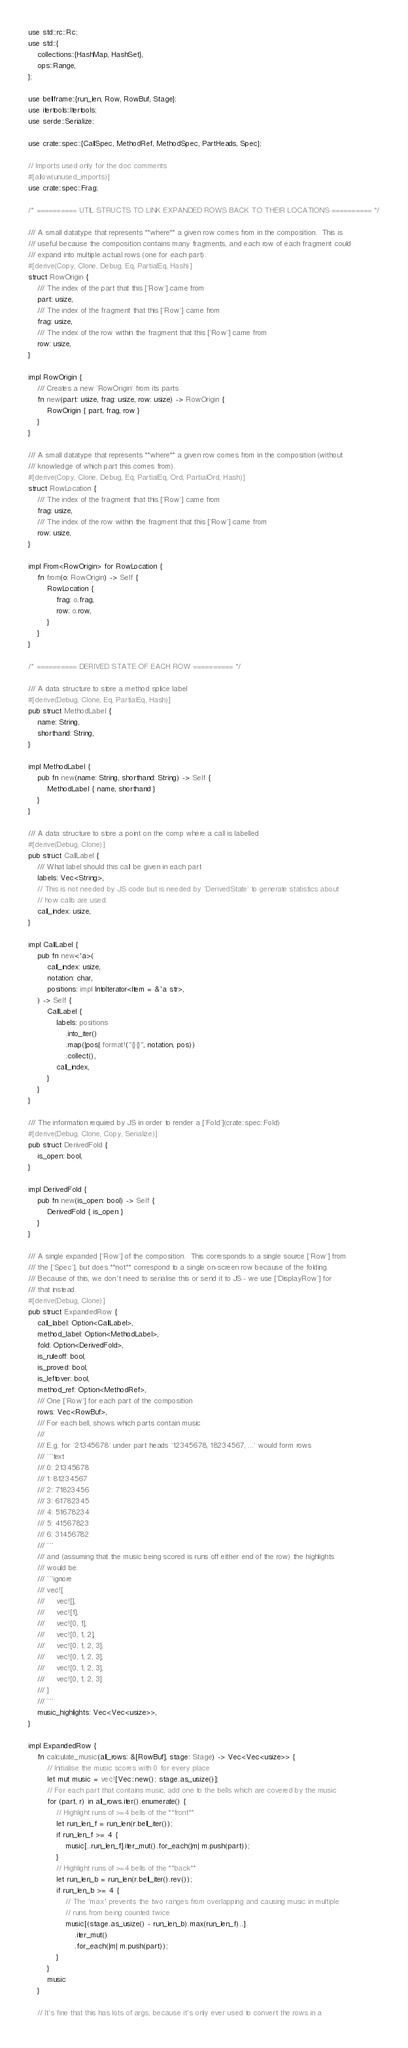<code> <loc_0><loc_0><loc_500><loc_500><_Rust_>use std::rc::Rc;
use std::{
    collections::{HashMap, HashSet},
    ops::Range,
};

use bellframe::{run_len, Row, RowBuf, Stage};
use itertools::Itertools;
use serde::Serialize;

use crate::spec::{CallSpec, MethodRef, MethodSpec, PartHeads, Spec};

// Imports used only for the doc comments
#[allow(unused_imports)]
use crate::spec::Frag;

/* ========== UTIL STRUCTS TO LINK EXPANDED ROWS BACK TO THEIR LOCATIONS ========== */

/// A small datatype that represents **where** a given row comes from in the composition.  This is
/// useful because the composition contains many fragments, and each row of each fragment could
/// expand into multiple actual rows (one for each part).
#[derive(Copy, Clone, Debug, Eq, PartialEq, Hash)]
struct RowOrigin {
    /// The index of the part that this [`Row`] came from
    part: usize,
    /// The index of the fragment that this [`Row`] came from
    frag: usize,
    /// The index of the row within the fragment that this [`Row`] came from
    row: usize,
}

impl RowOrigin {
    /// Creates a new `RowOrigin` from its parts
    fn new(part: usize, frag: usize, row: usize) -> RowOrigin {
        RowOrigin { part, frag, row }
    }
}

/// A small datatype that represents **where** a given row comes from in the composition (without
/// knowledge of which part this comes from).
#[derive(Copy, Clone, Debug, Eq, PartialEq, Ord, PartialOrd, Hash)]
struct RowLocation {
    /// The index of the fragment that this [`Row`] came from
    frag: usize,
    /// The index of the row within the fragment that this [`Row`] came from
    row: usize,
}

impl From<RowOrigin> for RowLocation {
    fn from(o: RowOrigin) -> Self {
        RowLocation {
            frag: o.frag,
            row: o.row,
        }
    }
}

/* ========== DERIVED STATE OF EACH ROW ========== */

/// A data structure to store a method splice label
#[derive(Debug, Clone, Eq, PartialEq, Hash)]
pub struct MethodLabel {
    name: String,
    shorthand: String,
}

impl MethodLabel {
    pub fn new(name: String, shorthand: String) -> Self {
        MethodLabel { name, shorthand }
    }
}

/// A data structure to store a point on the comp where a call is labelled
#[derive(Debug, Clone)]
pub struct CallLabel {
    /// What label should this call be given in each part
    labels: Vec<String>,
    // This is not needed by JS code but is needed by `DerivedState` to generate statistics about
    // how calls are used.
    call_index: usize,
}

impl CallLabel {
    pub fn new<'a>(
        call_index: usize,
        notation: char,
        positions: impl IntoIterator<Item = &'a str>,
    ) -> Self {
        CallLabel {
            labels: positions
                .into_iter()
                .map(|pos| format!("{}{}", notation, pos))
                .collect(),
            call_index,
        }
    }
}

/// The information required by JS in order to render a [`Fold`](crate::spec::Fold)
#[derive(Debug, Clone, Copy, Serialize)]
pub struct DerivedFold {
    is_open: bool,
}

impl DerivedFold {
    pub fn new(is_open: bool) -> Self {
        DerivedFold { is_open }
    }
}

/// A single expanded [`Row`] of the composition.  This corresponds to a single source [`Row`] from
/// the [`Spec`], but does **not** correspond to a single on-screen row because of the folding.
/// Because of this, we don't need to serialise this or send it to JS - we use [`DisplayRow`] for
/// that instead.
#[derive(Debug, Clone)]
pub struct ExpandedRow {
    call_label: Option<CallLabel>,
    method_label: Option<MethodLabel>,
    fold: Option<DerivedFold>,
    is_ruleoff: bool,
    is_proved: bool,
    is_leftover: bool,
    method_ref: Option<MethodRef>,
    /// One [`Row`] for each part of the composition
    rows: Vec<RowBuf>,
    /// For each bell, shows which parts contain music
    ///
    /// E.g. for `21345678` under part heads `12345678, 18234567, ...` would form rows
    /// ```text
    /// 0: 21345678
    /// 1: 81234567
    /// 2: 71823456
    /// 3: 61782345
    /// 4: 51678234
    /// 5: 41567823
    /// 6: 31456782
    /// ```
    /// and (assuming that the music being scored is runs off either end of the row) the highlights
    /// would be:
    /// ```ignore
    /// vec![
    ///     vec![],
    ///     vec![1],
    ///     vec![0, 1],
    ///     vec![0, 1, 2],
    ///     vec![0, 1, 2, 3],
    ///     vec![0, 1, 2, 3],
    ///     vec![0, 1, 2, 3],
    ///     vec![0, 1, 2, 3]
    /// ]
    /// ```
    music_highlights: Vec<Vec<usize>>,
}

impl ExpandedRow {
    fn calculate_music(all_rows: &[RowBuf], stage: Stage) -> Vec<Vec<usize>> {
        // Initialise the music scores with 0 for every place
        let mut music = vec![Vec::new(); stage.as_usize()];
        // For each part that contains music, add one to the bells which are covered by the music
        for (part, r) in all_rows.iter().enumerate() {
            // Highlight runs of >=4 bells of the **front**
            let run_len_f = run_len(r.bell_iter());
            if run_len_f >= 4 {
                music[..run_len_f].iter_mut().for_each(|m| m.push(part));
            }
            // Highlight runs of >=4 bells of the **back**
            let run_len_b = run_len(r.bell_iter().rev());
            if run_len_b >= 4 {
                // The 'max' prevents the two ranges from overlapping and causing music in multiple
                // runs from being counted twice
                music[(stage.as_usize() - run_len_b).max(run_len_f)..]
                    .iter_mut()
                    .for_each(|m| m.push(part));
            }
        }
        music
    }

    // It's fine that this has lots of args, because it's only ever used to convert the rows in a</code> 